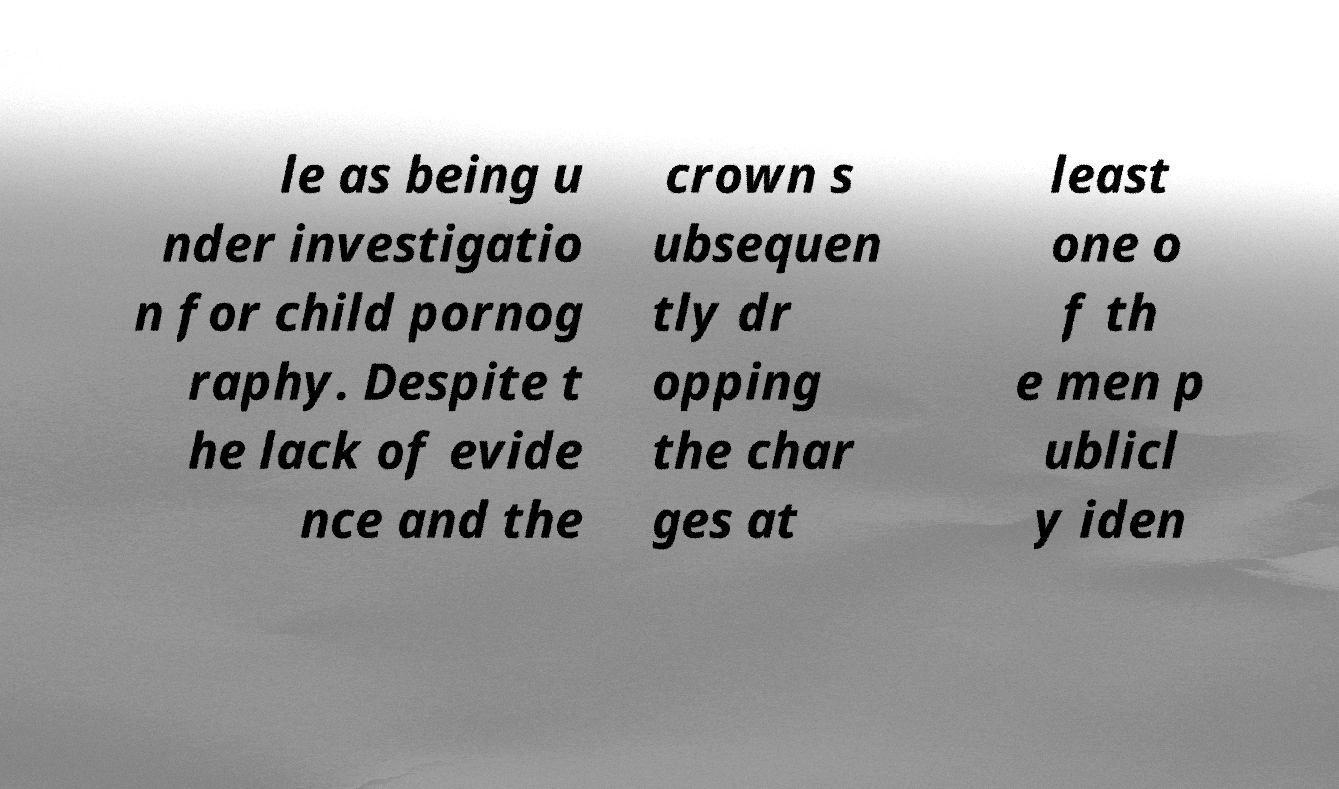Can you read and provide the text displayed in the image?This photo seems to have some interesting text. Can you extract and type it out for me? le as being u nder investigatio n for child pornog raphy. Despite t he lack of evide nce and the crown s ubsequen tly dr opping the char ges at least one o f th e men p ublicl y iden 